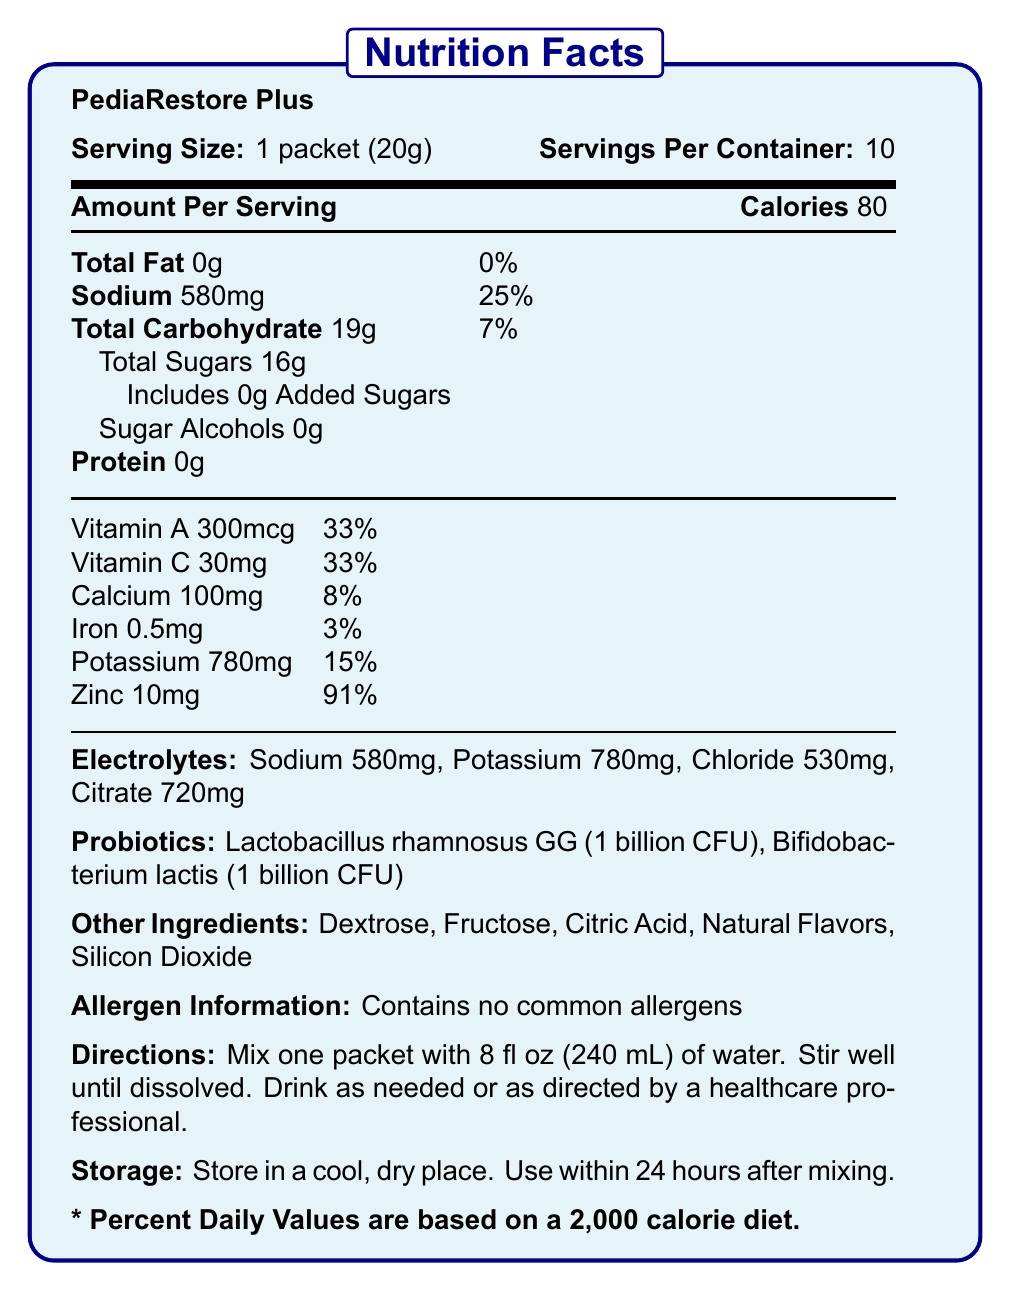What is the serving size of PediaRestore Plus? The serving size is listed clearly as "1 packet (20g)" in the document.
Answer: 1 packet (20g) How many servings are in each container of PediaRestore Plus? The document states "Servings Per Container: 10".
Answer: 10 How many calories are in one serving of PediaRestore Plus? The amount of calories per serving is specified as "Calories 80".
Answer: 80 calories What is the daily value percentage of sodium in one serving? The sodium content is listed as "Sodium 580mg" with "25%" as its daily value.
Answer: 25% List the probiotics included in PediaRestore Plus. The document mentions "Probiotics: Lactobacillus rhamnosus GG (1 billion CFU), Bifidobacterium lactis (1 billion CFU)".
Answer: Lactobacillus rhamnosus GG and Bifidobacterium lactis Which of the following vitamins has the highest daily value percentage in PediaRestore Plus? A. Vitamin A B. Vitamin C C. Calcium D. Iron Zinc has a daily value of 91%, which is higher than the daily values of the other vitamins listed.
Answer: D. Zinc What is the amount of total sugars per serving? The document notes "Total Sugars 16g".
Answer: 16g Is PediaRestore Plus suitable for children under 1 year old? The target age group is specified as "Children 1 year and older".
Answer: No What is the main function of PediaRestore Plus based on the document? The product benefits include "Rapidly replenishes fluids and electrolytes" and "Supports digestive health with probiotics".
Answer: Replenishes fluids and electrolytes, and supports digestive health with probiotics How much iron is in one serving of PediaRestore Plus? The iron content per serving is listed as "Iron 0.5mg".
Answer: 0.5mg What are the main electrolytes present in PediaRestore Plus? A. Sodium, Potassium, Chloride, Citrate B. Fluoride, Potassium, Citrate C. Sodium, Magnesium, Zinc The electrolytes are listed as "Sodium 580mg, Potassium 780mg, Chloride 530mg, Citrate 720mg".
Answer: A. Sodium, Potassium, Chloride, Citrate Can the storage information be determined from the document? The storage information is provided as "Store in a cool, dry place. Use within 24 hours after mixing."
Answer: Yes Summarize the key information provided in the document. The document provides nutritional details, ingredients, usage instructions, and benefits of the PediaRestore Plus product, emphasizing its role in rehydration and digestive health for children over one year old.
Answer: The document is a Nutrition Facts Label for PediaRestore Plus, a fortified pediatric oral rehydration solution with electrolytes and probiotics. It contains details on serving size, number of servings, caloric content, amounts of fat, sodium, carbohydrates (including sugar), and protein. It lists various vitamins and minerals, specific electrolytes, and probiotics. Additional information includes other ingredients, allergen information, directions for use, storage instructions, product benefits, target age group, and hospital compliance information. What is the main sweetener in the PediaRestore Plus? The document lists multiple ingredients (Dextrose, Fructose, etc.) but does not specify which is the main sweetener.
Answer: Cannot be determined 